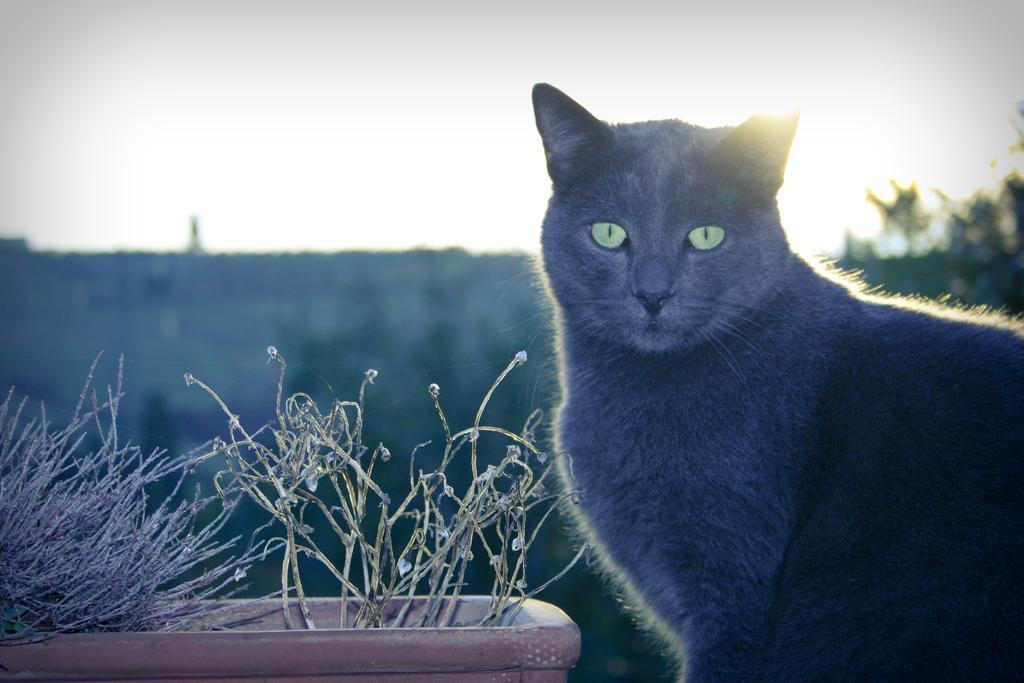Describe this image in one or two sentences. In this image we can see a cat. There are few plants and trees in the image. There is a blur background in the image. 